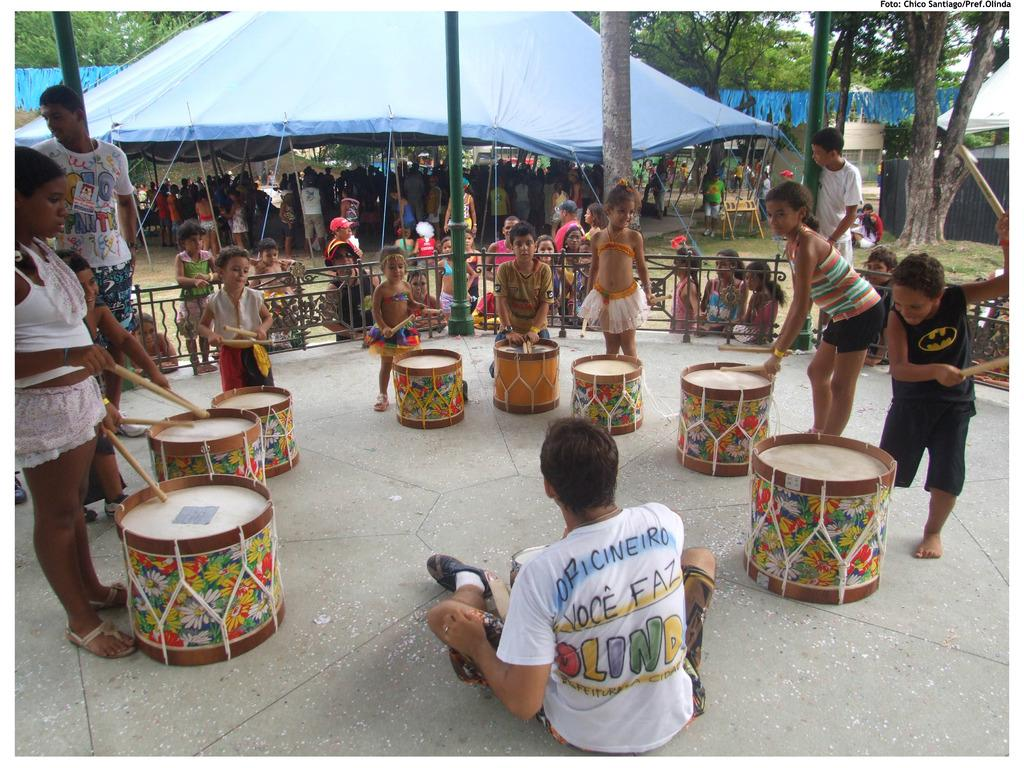What are the persons in the image doing? The persons in the image are playing drums. Can you describe the background of the image? There is a blue tent in the background of the image. What is the color of the tent? The tent is blue in color. Are there any other persons in the image besides the ones playing drums? Yes, there are persons standing under the tent. What is the ground covered with? The ground is covered with grass. What type of government is depicted in the image? There is no depiction of a government in the image; it features persons playing drums and a blue tent in the background. How many pigs can be seen interacting with the drummers in the image? There are no pigs present in the image. 